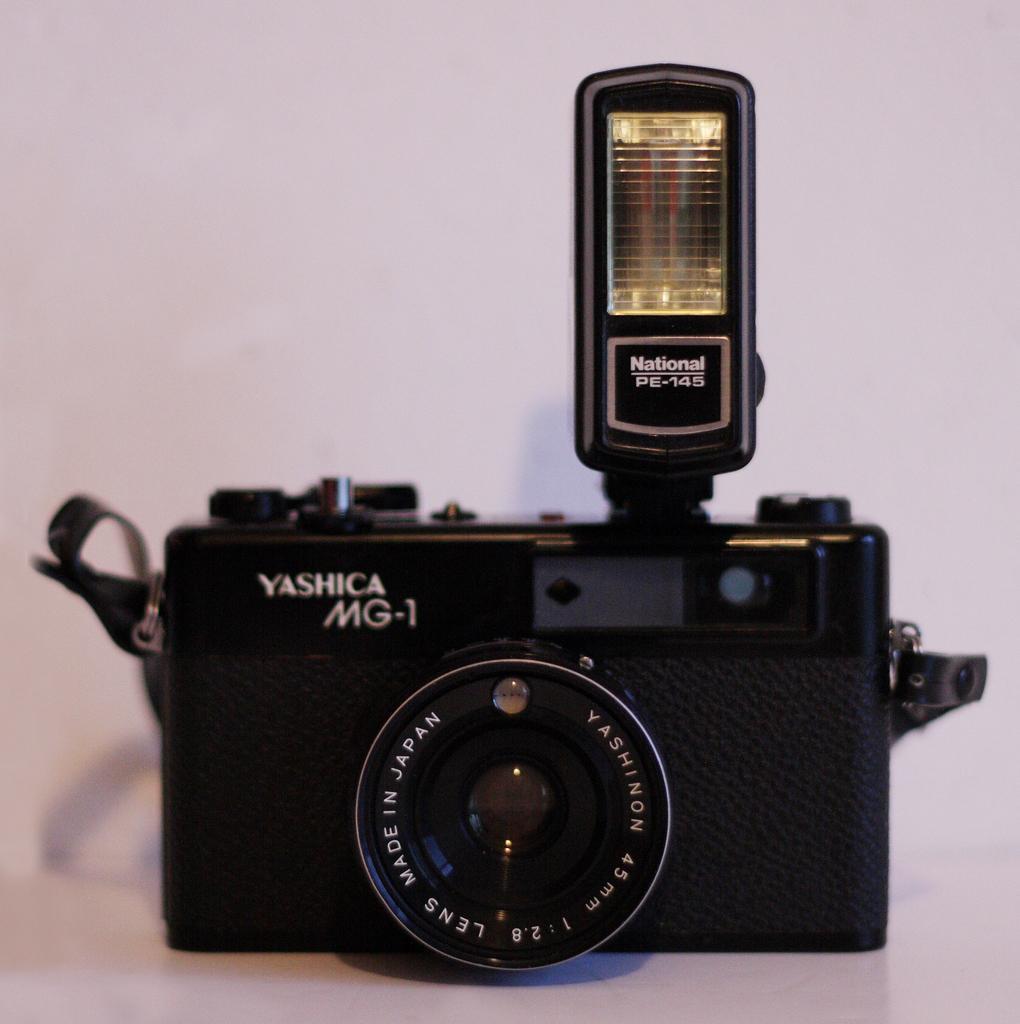How would you summarize this image in a sentence or two? In the image I can see a camera with something written on it. The camera is black in color. The camera is on a white color surface. The background of the image is white in color. 